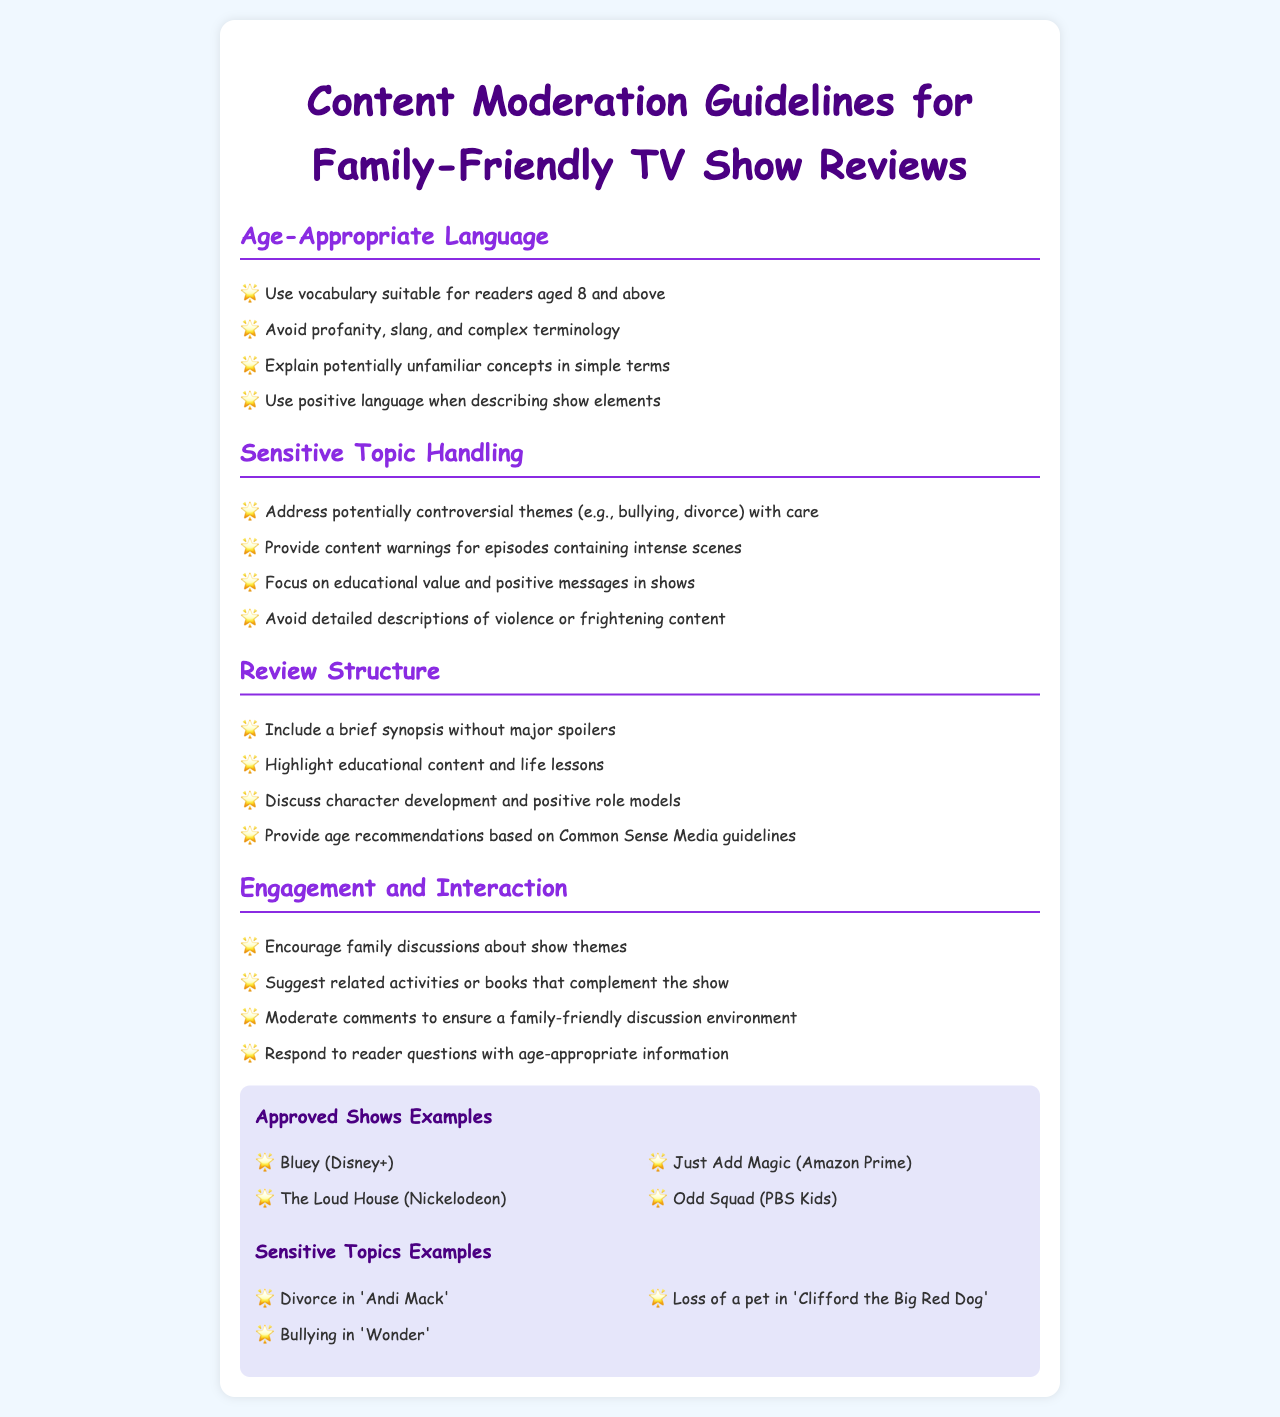what is the appropriate vocabulary age range? The guidelines specify that vocabulary should be suitable for readers aged 8 and above.
Answer: 8 and above what type of language should be avoided in reviews? The guidelines state to avoid profanity, slang, and complex terminology.
Answer: profanity, slang, complex terminology how should sensitive topics be addressed? The guidelines recommend addressing potentially controversial themes with care.
Answer: with care what is included in the review structure? The review structure includes a brief synopsis without major spoilers and highlights educational content.
Answer: brief synopsis, educational content name one of the approved shows listed. The document provides examples of approved shows for family-friendly reviews.
Answer: Bluey how should comments be moderated? The guidelines state to moderate comments to ensure a family-friendly discussion environment.
Answer: family-friendly discussion environment what should be provided for episodes with intense scenes? The guidelines specify to provide content warnings for episodes with intense scenes.
Answer: content warnings what is emphasized in handling sensitive topics? The guidelines emphasize focusing on educational value and positive messages in shows.
Answer: educational value and positive messages how can families engage with the show's themes? The guidelines suggest encouraging family discussions about show themes.
Answer: family discussions 